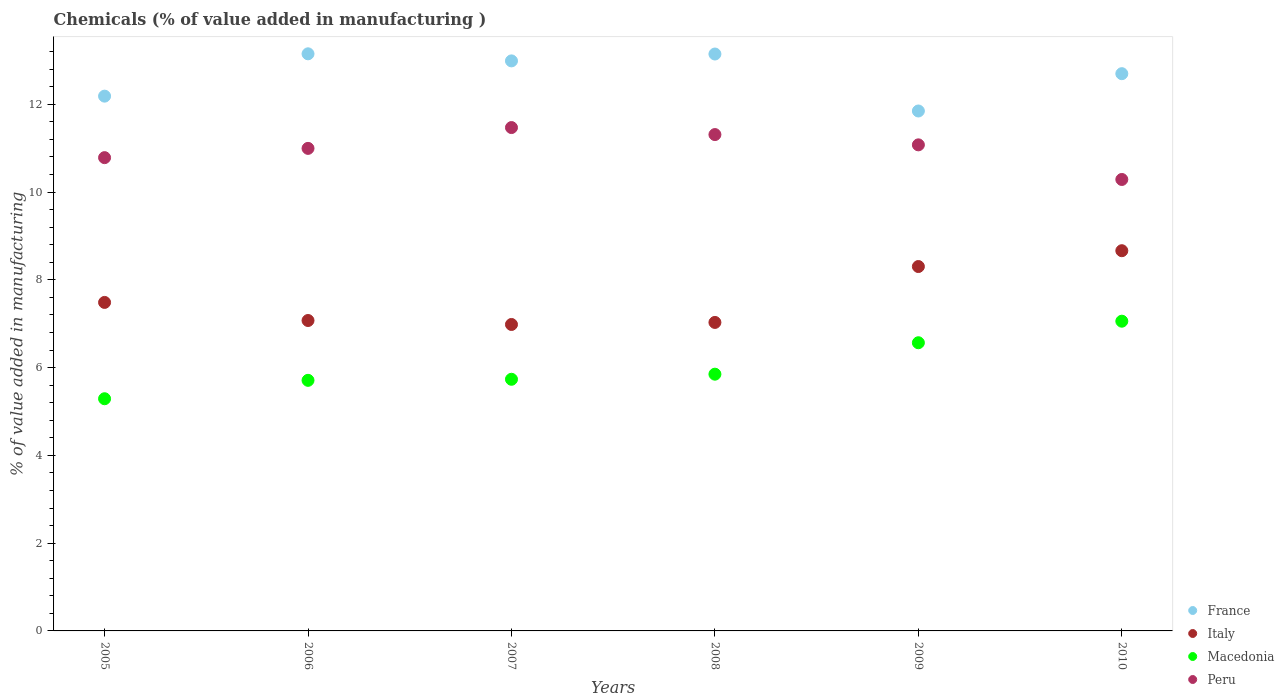What is the value added in manufacturing chemicals in Peru in 2010?
Offer a very short reply. 10.29. Across all years, what is the maximum value added in manufacturing chemicals in France?
Your response must be concise. 13.15. Across all years, what is the minimum value added in manufacturing chemicals in Peru?
Give a very brief answer. 10.29. In which year was the value added in manufacturing chemicals in France minimum?
Provide a succinct answer. 2009. What is the total value added in manufacturing chemicals in Macedonia in the graph?
Your response must be concise. 36.21. What is the difference between the value added in manufacturing chemicals in Italy in 2006 and that in 2008?
Provide a succinct answer. 0.04. What is the difference between the value added in manufacturing chemicals in Peru in 2006 and the value added in manufacturing chemicals in Macedonia in 2009?
Keep it short and to the point. 4.43. What is the average value added in manufacturing chemicals in Italy per year?
Your response must be concise. 7.59. In the year 2008, what is the difference between the value added in manufacturing chemicals in Peru and value added in manufacturing chemicals in France?
Your answer should be compact. -1.84. What is the ratio of the value added in manufacturing chemicals in Peru in 2005 to that in 2007?
Ensure brevity in your answer.  0.94. Is the value added in manufacturing chemicals in Peru in 2006 less than that in 2007?
Your answer should be very brief. Yes. Is the difference between the value added in manufacturing chemicals in Peru in 2009 and 2010 greater than the difference between the value added in manufacturing chemicals in France in 2009 and 2010?
Give a very brief answer. Yes. What is the difference between the highest and the second highest value added in manufacturing chemicals in France?
Your response must be concise. 0. What is the difference between the highest and the lowest value added in manufacturing chemicals in Peru?
Your response must be concise. 1.18. Does the value added in manufacturing chemicals in Peru monotonically increase over the years?
Offer a terse response. No. How many dotlines are there?
Keep it short and to the point. 4. How many years are there in the graph?
Provide a short and direct response. 6. Are the values on the major ticks of Y-axis written in scientific E-notation?
Your answer should be compact. No. How many legend labels are there?
Offer a terse response. 4. How are the legend labels stacked?
Your answer should be very brief. Vertical. What is the title of the graph?
Your response must be concise. Chemicals (% of value added in manufacturing ). Does "Greenland" appear as one of the legend labels in the graph?
Your answer should be compact. No. What is the label or title of the Y-axis?
Provide a short and direct response. % of value added in manufacturing. What is the % of value added in manufacturing of France in 2005?
Your response must be concise. 12.19. What is the % of value added in manufacturing in Italy in 2005?
Keep it short and to the point. 7.49. What is the % of value added in manufacturing in Macedonia in 2005?
Your answer should be very brief. 5.29. What is the % of value added in manufacturing of Peru in 2005?
Offer a terse response. 10.78. What is the % of value added in manufacturing of France in 2006?
Give a very brief answer. 13.15. What is the % of value added in manufacturing in Italy in 2006?
Your response must be concise. 7.07. What is the % of value added in manufacturing in Macedonia in 2006?
Provide a succinct answer. 5.71. What is the % of value added in manufacturing in Peru in 2006?
Offer a terse response. 11. What is the % of value added in manufacturing of France in 2007?
Your answer should be compact. 12.99. What is the % of value added in manufacturing in Italy in 2007?
Offer a very short reply. 6.98. What is the % of value added in manufacturing of Macedonia in 2007?
Offer a very short reply. 5.73. What is the % of value added in manufacturing in Peru in 2007?
Your response must be concise. 11.47. What is the % of value added in manufacturing in France in 2008?
Your answer should be compact. 13.15. What is the % of value added in manufacturing of Italy in 2008?
Keep it short and to the point. 7.03. What is the % of value added in manufacturing of Macedonia in 2008?
Your answer should be very brief. 5.85. What is the % of value added in manufacturing in Peru in 2008?
Your answer should be compact. 11.31. What is the % of value added in manufacturing in France in 2009?
Make the answer very short. 11.85. What is the % of value added in manufacturing of Italy in 2009?
Your response must be concise. 8.3. What is the % of value added in manufacturing of Macedonia in 2009?
Ensure brevity in your answer.  6.57. What is the % of value added in manufacturing of Peru in 2009?
Your answer should be compact. 11.08. What is the % of value added in manufacturing of France in 2010?
Provide a succinct answer. 12.7. What is the % of value added in manufacturing of Italy in 2010?
Offer a very short reply. 8.66. What is the % of value added in manufacturing in Macedonia in 2010?
Offer a terse response. 7.06. What is the % of value added in manufacturing in Peru in 2010?
Your answer should be very brief. 10.29. Across all years, what is the maximum % of value added in manufacturing in France?
Offer a very short reply. 13.15. Across all years, what is the maximum % of value added in manufacturing in Italy?
Offer a terse response. 8.66. Across all years, what is the maximum % of value added in manufacturing of Macedonia?
Ensure brevity in your answer.  7.06. Across all years, what is the maximum % of value added in manufacturing in Peru?
Ensure brevity in your answer.  11.47. Across all years, what is the minimum % of value added in manufacturing of France?
Your answer should be very brief. 11.85. Across all years, what is the minimum % of value added in manufacturing of Italy?
Provide a short and direct response. 6.98. Across all years, what is the minimum % of value added in manufacturing in Macedonia?
Make the answer very short. 5.29. Across all years, what is the minimum % of value added in manufacturing in Peru?
Keep it short and to the point. 10.29. What is the total % of value added in manufacturing in France in the graph?
Your response must be concise. 76.02. What is the total % of value added in manufacturing in Italy in the graph?
Your response must be concise. 45.54. What is the total % of value added in manufacturing of Macedonia in the graph?
Provide a short and direct response. 36.21. What is the total % of value added in manufacturing of Peru in the graph?
Ensure brevity in your answer.  65.92. What is the difference between the % of value added in manufacturing in France in 2005 and that in 2006?
Ensure brevity in your answer.  -0.96. What is the difference between the % of value added in manufacturing in Italy in 2005 and that in 2006?
Your response must be concise. 0.41. What is the difference between the % of value added in manufacturing in Macedonia in 2005 and that in 2006?
Your answer should be very brief. -0.42. What is the difference between the % of value added in manufacturing in Peru in 2005 and that in 2006?
Ensure brevity in your answer.  -0.21. What is the difference between the % of value added in manufacturing of France in 2005 and that in 2007?
Offer a terse response. -0.8. What is the difference between the % of value added in manufacturing in Italy in 2005 and that in 2007?
Make the answer very short. 0.5. What is the difference between the % of value added in manufacturing of Macedonia in 2005 and that in 2007?
Your response must be concise. -0.44. What is the difference between the % of value added in manufacturing of Peru in 2005 and that in 2007?
Provide a short and direct response. -0.69. What is the difference between the % of value added in manufacturing in France in 2005 and that in 2008?
Your answer should be compact. -0.96. What is the difference between the % of value added in manufacturing in Italy in 2005 and that in 2008?
Offer a very short reply. 0.46. What is the difference between the % of value added in manufacturing in Macedonia in 2005 and that in 2008?
Keep it short and to the point. -0.56. What is the difference between the % of value added in manufacturing in Peru in 2005 and that in 2008?
Offer a terse response. -0.53. What is the difference between the % of value added in manufacturing in France in 2005 and that in 2009?
Your answer should be compact. 0.34. What is the difference between the % of value added in manufacturing in Italy in 2005 and that in 2009?
Offer a terse response. -0.82. What is the difference between the % of value added in manufacturing in Macedonia in 2005 and that in 2009?
Offer a very short reply. -1.28. What is the difference between the % of value added in manufacturing of Peru in 2005 and that in 2009?
Ensure brevity in your answer.  -0.29. What is the difference between the % of value added in manufacturing in France in 2005 and that in 2010?
Your response must be concise. -0.51. What is the difference between the % of value added in manufacturing of Italy in 2005 and that in 2010?
Give a very brief answer. -1.18. What is the difference between the % of value added in manufacturing of Macedonia in 2005 and that in 2010?
Provide a short and direct response. -1.77. What is the difference between the % of value added in manufacturing in Peru in 2005 and that in 2010?
Provide a short and direct response. 0.5. What is the difference between the % of value added in manufacturing in France in 2006 and that in 2007?
Provide a succinct answer. 0.16. What is the difference between the % of value added in manufacturing in Italy in 2006 and that in 2007?
Provide a short and direct response. 0.09. What is the difference between the % of value added in manufacturing in Macedonia in 2006 and that in 2007?
Provide a short and direct response. -0.02. What is the difference between the % of value added in manufacturing of Peru in 2006 and that in 2007?
Provide a succinct answer. -0.47. What is the difference between the % of value added in manufacturing of France in 2006 and that in 2008?
Provide a short and direct response. 0. What is the difference between the % of value added in manufacturing of Italy in 2006 and that in 2008?
Your answer should be compact. 0.04. What is the difference between the % of value added in manufacturing of Macedonia in 2006 and that in 2008?
Ensure brevity in your answer.  -0.14. What is the difference between the % of value added in manufacturing of Peru in 2006 and that in 2008?
Give a very brief answer. -0.31. What is the difference between the % of value added in manufacturing in France in 2006 and that in 2009?
Provide a succinct answer. 1.3. What is the difference between the % of value added in manufacturing in Italy in 2006 and that in 2009?
Offer a terse response. -1.23. What is the difference between the % of value added in manufacturing in Macedonia in 2006 and that in 2009?
Your response must be concise. -0.86. What is the difference between the % of value added in manufacturing of Peru in 2006 and that in 2009?
Make the answer very short. -0.08. What is the difference between the % of value added in manufacturing in France in 2006 and that in 2010?
Ensure brevity in your answer.  0.45. What is the difference between the % of value added in manufacturing of Italy in 2006 and that in 2010?
Ensure brevity in your answer.  -1.59. What is the difference between the % of value added in manufacturing of Macedonia in 2006 and that in 2010?
Ensure brevity in your answer.  -1.35. What is the difference between the % of value added in manufacturing in Peru in 2006 and that in 2010?
Ensure brevity in your answer.  0.71. What is the difference between the % of value added in manufacturing of France in 2007 and that in 2008?
Ensure brevity in your answer.  -0.16. What is the difference between the % of value added in manufacturing of Italy in 2007 and that in 2008?
Give a very brief answer. -0.05. What is the difference between the % of value added in manufacturing of Macedonia in 2007 and that in 2008?
Make the answer very short. -0.12. What is the difference between the % of value added in manufacturing of Peru in 2007 and that in 2008?
Offer a very short reply. 0.16. What is the difference between the % of value added in manufacturing in France in 2007 and that in 2009?
Make the answer very short. 1.14. What is the difference between the % of value added in manufacturing of Italy in 2007 and that in 2009?
Make the answer very short. -1.32. What is the difference between the % of value added in manufacturing in Macedonia in 2007 and that in 2009?
Ensure brevity in your answer.  -0.83. What is the difference between the % of value added in manufacturing in Peru in 2007 and that in 2009?
Provide a succinct answer. 0.39. What is the difference between the % of value added in manufacturing in France in 2007 and that in 2010?
Keep it short and to the point. 0.29. What is the difference between the % of value added in manufacturing in Italy in 2007 and that in 2010?
Your response must be concise. -1.68. What is the difference between the % of value added in manufacturing in Macedonia in 2007 and that in 2010?
Make the answer very short. -1.32. What is the difference between the % of value added in manufacturing of Peru in 2007 and that in 2010?
Your answer should be compact. 1.18. What is the difference between the % of value added in manufacturing in France in 2008 and that in 2009?
Provide a short and direct response. 1.3. What is the difference between the % of value added in manufacturing of Italy in 2008 and that in 2009?
Your answer should be compact. -1.27. What is the difference between the % of value added in manufacturing of Macedonia in 2008 and that in 2009?
Keep it short and to the point. -0.72. What is the difference between the % of value added in manufacturing of Peru in 2008 and that in 2009?
Offer a terse response. 0.23. What is the difference between the % of value added in manufacturing of France in 2008 and that in 2010?
Give a very brief answer. 0.45. What is the difference between the % of value added in manufacturing in Italy in 2008 and that in 2010?
Your response must be concise. -1.63. What is the difference between the % of value added in manufacturing of Macedonia in 2008 and that in 2010?
Give a very brief answer. -1.21. What is the difference between the % of value added in manufacturing in Peru in 2008 and that in 2010?
Provide a succinct answer. 1.02. What is the difference between the % of value added in manufacturing in France in 2009 and that in 2010?
Your response must be concise. -0.85. What is the difference between the % of value added in manufacturing of Italy in 2009 and that in 2010?
Provide a succinct answer. -0.36. What is the difference between the % of value added in manufacturing in Macedonia in 2009 and that in 2010?
Your answer should be compact. -0.49. What is the difference between the % of value added in manufacturing in Peru in 2009 and that in 2010?
Provide a short and direct response. 0.79. What is the difference between the % of value added in manufacturing of France in 2005 and the % of value added in manufacturing of Italy in 2006?
Keep it short and to the point. 5.11. What is the difference between the % of value added in manufacturing in France in 2005 and the % of value added in manufacturing in Macedonia in 2006?
Your answer should be very brief. 6.48. What is the difference between the % of value added in manufacturing in France in 2005 and the % of value added in manufacturing in Peru in 2006?
Offer a very short reply. 1.19. What is the difference between the % of value added in manufacturing in Italy in 2005 and the % of value added in manufacturing in Macedonia in 2006?
Your answer should be very brief. 1.78. What is the difference between the % of value added in manufacturing of Italy in 2005 and the % of value added in manufacturing of Peru in 2006?
Your answer should be compact. -3.51. What is the difference between the % of value added in manufacturing of Macedonia in 2005 and the % of value added in manufacturing of Peru in 2006?
Your answer should be compact. -5.71. What is the difference between the % of value added in manufacturing of France in 2005 and the % of value added in manufacturing of Italy in 2007?
Offer a very short reply. 5.2. What is the difference between the % of value added in manufacturing in France in 2005 and the % of value added in manufacturing in Macedonia in 2007?
Ensure brevity in your answer.  6.45. What is the difference between the % of value added in manufacturing in France in 2005 and the % of value added in manufacturing in Peru in 2007?
Make the answer very short. 0.72. What is the difference between the % of value added in manufacturing of Italy in 2005 and the % of value added in manufacturing of Macedonia in 2007?
Your response must be concise. 1.75. What is the difference between the % of value added in manufacturing in Italy in 2005 and the % of value added in manufacturing in Peru in 2007?
Keep it short and to the point. -3.98. What is the difference between the % of value added in manufacturing of Macedonia in 2005 and the % of value added in manufacturing of Peru in 2007?
Ensure brevity in your answer.  -6.18. What is the difference between the % of value added in manufacturing in France in 2005 and the % of value added in manufacturing in Italy in 2008?
Provide a succinct answer. 5.16. What is the difference between the % of value added in manufacturing of France in 2005 and the % of value added in manufacturing of Macedonia in 2008?
Make the answer very short. 6.34. What is the difference between the % of value added in manufacturing in France in 2005 and the % of value added in manufacturing in Peru in 2008?
Offer a terse response. 0.88. What is the difference between the % of value added in manufacturing of Italy in 2005 and the % of value added in manufacturing of Macedonia in 2008?
Make the answer very short. 1.64. What is the difference between the % of value added in manufacturing of Italy in 2005 and the % of value added in manufacturing of Peru in 2008?
Make the answer very short. -3.82. What is the difference between the % of value added in manufacturing in Macedonia in 2005 and the % of value added in manufacturing in Peru in 2008?
Your answer should be very brief. -6.02. What is the difference between the % of value added in manufacturing in France in 2005 and the % of value added in manufacturing in Italy in 2009?
Make the answer very short. 3.88. What is the difference between the % of value added in manufacturing of France in 2005 and the % of value added in manufacturing of Macedonia in 2009?
Your answer should be compact. 5.62. What is the difference between the % of value added in manufacturing of France in 2005 and the % of value added in manufacturing of Peru in 2009?
Offer a terse response. 1.11. What is the difference between the % of value added in manufacturing of Italy in 2005 and the % of value added in manufacturing of Macedonia in 2009?
Offer a very short reply. 0.92. What is the difference between the % of value added in manufacturing in Italy in 2005 and the % of value added in manufacturing in Peru in 2009?
Your response must be concise. -3.59. What is the difference between the % of value added in manufacturing in Macedonia in 2005 and the % of value added in manufacturing in Peru in 2009?
Offer a very short reply. -5.79. What is the difference between the % of value added in manufacturing of France in 2005 and the % of value added in manufacturing of Italy in 2010?
Ensure brevity in your answer.  3.52. What is the difference between the % of value added in manufacturing of France in 2005 and the % of value added in manufacturing of Macedonia in 2010?
Make the answer very short. 5.13. What is the difference between the % of value added in manufacturing of France in 2005 and the % of value added in manufacturing of Peru in 2010?
Offer a terse response. 1.9. What is the difference between the % of value added in manufacturing in Italy in 2005 and the % of value added in manufacturing in Macedonia in 2010?
Provide a succinct answer. 0.43. What is the difference between the % of value added in manufacturing in Italy in 2005 and the % of value added in manufacturing in Peru in 2010?
Provide a short and direct response. -2.8. What is the difference between the % of value added in manufacturing of Macedonia in 2005 and the % of value added in manufacturing of Peru in 2010?
Your answer should be very brief. -5. What is the difference between the % of value added in manufacturing of France in 2006 and the % of value added in manufacturing of Italy in 2007?
Offer a very short reply. 6.17. What is the difference between the % of value added in manufacturing in France in 2006 and the % of value added in manufacturing in Macedonia in 2007?
Give a very brief answer. 7.42. What is the difference between the % of value added in manufacturing of France in 2006 and the % of value added in manufacturing of Peru in 2007?
Your answer should be compact. 1.68. What is the difference between the % of value added in manufacturing of Italy in 2006 and the % of value added in manufacturing of Macedonia in 2007?
Provide a short and direct response. 1.34. What is the difference between the % of value added in manufacturing of Italy in 2006 and the % of value added in manufacturing of Peru in 2007?
Your answer should be compact. -4.4. What is the difference between the % of value added in manufacturing of Macedonia in 2006 and the % of value added in manufacturing of Peru in 2007?
Offer a very short reply. -5.76. What is the difference between the % of value added in manufacturing in France in 2006 and the % of value added in manufacturing in Italy in 2008?
Ensure brevity in your answer.  6.12. What is the difference between the % of value added in manufacturing of France in 2006 and the % of value added in manufacturing of Macedonia in 2008?
Your answer should be compact. 7.3. What is the difference between the % of value added in manufacturing of France in 2006 and the % of value added in manufacturing of Peru in 2008?
Make the answer very short. 1.84. What is the difference between the % of value added in manufacturing in Italy in 2006 and the % of value added in manufacturing in Macedonia in 2008?
Make the answer very short. 1.22. What is the difference between the % of value added in manufacturing of Italy in 2006 and the % of value added in manufacturing of Peru in 2008?
Keep it short and to the point. -4.24. What is the difference between the % of value added in manufacturing of Macedonia in 2006 and the % of value added in manufacturing of Peru in 2008?
Offer a terse response. -5.6. What is the difference between the % of value added in manufacturing of France in 2006 and the % of value added in manufacturing of Italy in 2009?
Offer a very short reply. 4.85. What is the difference between the % of value added in manufacturing in France in 2006 and the % of value added in manufacturing in Macedonia in 2009?
Keep it short and to the point. 6.58. What is the difference between the % of value added in manufacturing in France in 2006 and the % of value added in manufacturing in Peru in 2009?
Offer a terse response. 2.07. What is the difference between the % of value added in manufacturing of Italy in 2006 and the % of value added in manufacturing of Macedonia in 2009?
Provide a short and direct response. 0.51. What is the difference between the % of value added in manufacturing of Italy in 2006 and the % of value added in manufacturing of Peru in 2009?
Provide a short and direct response. -4. What is the difference between the % of value added in manufacturing in Macedonia in 2006 and the % of value added in manufacturing in Peru in 2009?
Your answer should be very brief. -5.37. What is the difference between the % of value added in manufacturing in France in 2006 and the % of value added in manufacturing in Italy in 2010?
Offer a very short reply. 4.49. What is the difference between the % of value added in manufacturing in France in 2006 and the % of value added in manufacturing in Macedonia in 2010?
Provide a short and direct response. 6.09. What is the difference between the % of value added in manufacturing of France in 2006 and the % of value added in manufacturing of Peru in 2010?
Give a very brief answer. 2.86. What is the difference between the % of value added in manufacturing in Italy in 2006 and the % of value added in manufacturing in Macedonia in 2010?
Offer a terse response. 0.02. What is the difference between the % of value added in manufacturing of Italy in 2006 and the % of value added in manufacturing of Peru in 2010?
Give a very brief answer. -3.21. What is the difference between the % of value added in manufacturing in Macedonia in 2006 and the % of value added in manufacturing in Peru in 2010?
Your answer should be very brief. -4.58. What is the difference between the % of value added in manufacturing of France in 2007 and the % of value added in manufacturing of Italy in 2008?
Your response must be concise. 5.96. What is the difference between the % of value added in manufacturing in France in 2007 and the % of value added in manufacturing in Macedonia in 2008?
Offer a very short reply. 7.14. What is the difference between the % of value added in manufacturing of France in 2007 and the % of value added in manufacturing of Peru in 2008?
Ensure brevity in your answer.  1.68. What is the difference between the % of value added in manufacturing of Italy in 2007 and the % of value added in manufacturing of Macedonia in 2008?
Give a very brief answer. 1.13. What is the difference between the % of value added in manufacturing of Italy in 2007 and the % of value added in manufacturing of Peru in 2008?
Give a very brief answer. -4.33. What is the difference between the % of value added in manufacturing in Macedonia in 2007 and the % of value added in manufacturing in Peru in 2008?
Your response must be concise. -5.58. What is the difference between the % of value added in manufacturing of France in 2007 and the % of value added in manufacturing of Italy in 2009?
Make the answer very short. 4.69. What is the difference between the % of value added in manufacturing in France in 2007 and the % of value added in manufacturing in Macedonia in 2009?
Offer a very short reply. 6.42. What is the difference between the % of value added in manufacturing in France in 2007 and the % of value added in manufacturing in Peru in 2009?
Offer a terse response. 1.91. What is the difference between the % of value added in manufacturing in Italy in 2007 and the % of value added in manufacturing in Macedonia in 2009?
Provide a short and direct response. 0.42. What is the difference between the % of value added in manufacturing of Italy in 2007 and the % of value added in manufacturing of Peru in 2009?
Provide a succinct answer. -4.09. What is the difference between the % of value added in manufacturing of Macedonia in 2007 and the % of value added in manufacturing of Peru in 2009?
Provide a short and direct response. -5.34. What is the difference between the % of value added in manufacturing of France in 2007 and the % of value added in manufacturing of Italy in 2010?
Ensure brevity in your answer.  4.33. What is the difference between the % of value added in manufacturing in France in 2007 and the % of value added in manufacturing in Macedonia in 2010?
Give a very brief answer. 5.93. What is the difference between the % of value added in manufacturing in France in 2007 and the % of value added in manufacturing in Peru in 2010?
Your answer should be compact. 2.7. What is the difference between the % of value added in manufacturing in Italy in 2007 and the % of value added in manufacturing in Macedonia in 2010?
Ensure brevity in your answer.  -0.07. What is the difference between the % of value added in manufacturing in Italy in 2007 and the % of value added in manufacturing in Peru in 2010?
Offer a very short reply. -3.3. What is the difference between the % of value added in manufacturing of Macedonia in 2007 and the % of value added in manufacturing of Peru in 2010?
Your response must be concise. -4.55. What is the difference between the % of value added in manufacturing of France in 2008 and the % of value added in manufacturing of Italy in 2009?
Offer a terse response. 4.84. What is the difference between the % of value added in manufacturing of France in 2008 and the % of value added in manufacturing of Macedonia in 2009?
Ensure brevity in your answer.  6.58. What is the difference between the % of value added in manufacturing in France in 2008 and the % of value added in manufacturing in Peru in 2009?
Make the answer very short. 2.07. What is the difference between the % of value added in manufacturing of Italy in 2008 and the % of value added in manufacturing of Macedonia in 2009?
Ensure brevity in your answer.  0.46. What is the difference between the % of value added in manufacturing in Italy in 2008 and the % of value added in manufacturing in Peru in 2009?
Offer a very short reply. -4.05. What is the difference between the % of value added in manufacturing in Macedonia in 2008 and the % of value added in manufacturing in Peru in 2009?
Provide a succinct answer. -5.23. What is the difference between the % of value added in manufacturing of France in 2008 and the % of value added in manufacturing of Italy in 2010?
Ensure brevity in your answer.  4.48. What is the difference between the % of value added in manufacturing in France in 2008 and the % of value added in manufacturing in Macedonia in 2010?
Make the answer very short. 6.09. What is the difference between the % of value added in manufacturing in France in 2008 and the % of value added in manufacturing in Peru in 2010?
Provide a short and direct response. 2.86. What is the difference between the % of value added in manufacturing in Italy in 2008 and the % of value added in manufacturing in Macedonia in 2010?
Keep it short and to the point. -0.03. What is the difference between the % of value added in manufacturing of Italy in 2008 and the % of value added in manufacturing of Peru in 2010?
Make the answer very short. -3.26. What is the difference between the % of value added in manufacturing of Macedonia in 2008 and the % of value added in manufacturing of Peru in 2010?
Keep it short and to the point. -4.44. What is the difference between the % of value added in manufacturing in France in 2009 and the % of value added in manufacturing in Italy in 2010?
Offer a terse response. 3.18. What is the difference between the % of value added in manufacturing in France in 2009 and the % of value added in manufacturing in Macedonia in 2010?
Offer a terse response. 4.79. What is the difference between the % of value added in manufacturing in France in 2009 and the % of value added in manufacturing in Peru in 2010?
Your answer should be very brief. 1.56. What is the difference between the % of value added in manufacturing of Italy in 2009 and the % of value added in manufacturing of Macedonia in 2010?
Your answer should be very brief. 1.25. What is the difference between the % of value added in manufacturing of Italy in 2009 and the % of value added in manufacturing of Peru in 2010?
Offer a very short reply. -1.98. What is the difference between the % of value added in manufacturing in Macedonia in 2009 and the % of value added in manufacturing in Peru in 2010?
Offer a terse response. -3.72. What is the average % of value added in manufacturing in France per year?
Keep it short and to the point. 12.67. What is the average % of value added in manufacturing of Italy per year?
Offer a terse response. 7.59. What is the average % of value added in manufacturing of Macedonia per year?
Offer a very short reply. 6.04. What is the average % of value added in manufacturing of Peru per year?
Your response must be concise. 10.99. In the year 2005, what is the difference between the % of value added in manufacturing in France and % of value added in manufacturing in Italy?
Offer a terse response. 4.7. In the year 2005, what is the difference between the % of value added in manufacturing of France and % of value added in manufacturing of Macedonia?
Your answer should be compact. 6.9. In the year 2005, what is the difference between the % of value added in manufacturing of France and % of value added in manufacturing of Peru?
Offer a very short reply. 1.4. In the year 2005, what is the difference between the % of value added in manufacturing in Italy and % of value added in manufacturing in Macedonia?
Provide a short and direct response. 2.19. In the year 2005, what is the difference between the % of value added in manufacturing of Italy and % of value added in manufacturing of Peru?
Offer a very short reply. -3.3. In the year 2005, what is the difference between the % of value added in manufacturing of Macedonia and % of value added in manufacturing of Peru?
Provide a short and direct response. -5.49. In the year 2006, what is the difference between the % of value added in manufacturing in France and % of value added in manufacturing in Italy?
Offer a very short reply. 6.08. In the year 2006, what is the difference between the % of value added in manufacturing in France and % of value added in manufacturing in Macedonia?
Provide a succinct answer. 7.44. In the year 2006, what is the difference between the % of value added in manufacturing of France and % of value added in manufacturing of Peru?
Give a very brief answer. 2.15. In the year 2006, what is the difference between the % of value added in manufacturing in Italy and % of value added in manufacturing in Macedonia?
Your answer should be compact. 1.36. In the year 2006, what is the difference between the % of value added in manufacturing in Italy and % of value added in manufacturing in Peru?
Offer a terse response. -3.92. In the year 2006, what is the difference between the % of value added in manufacturing of Macedonia and % of value added in manufacturing of Peru?
Provide a short and direct response. -5.29. In the year 2007, what is the difference between the % of value added in manufacturing of France and % of value added in manufacturing of Italy?
Your answer should be compact. 6.01. In the year 2007, what is the difference between the % of value added in manufacturing in France and % of value added in manufacturing in Macedonia?
Ensure brevity in your answer.  7.25. In the year 2007, what is the difference between the % of value added in manufacturing of France and % of value added in manufacturing of Peru?
Provide a short and direct response. 1.52. In the year 2007, what is the difference between the % of value added in manufacturing in Italy and % of value added in manufacturing in Macedonia?
Offer a terse response. 1.25. In the year 2007, what is the difference between the % of value added in manufacturing in Italy and % of value added in manufacturing in Peru?
Provide a short and direct response. -4.49. In the year 2007, what is the difference between the % of value added in manufacturing in Macedonia and % of value added in manufacturing in Peru?
Your answer should be very brief. -5.74. In the year 2008, what is the difference between the % of value added in manufacturing of France and % of value added in manufacturing of Italy?
Your answer should be compact. 6.12. In the year 2008, what is the difference between the % of value added in manufacturing of France and % of value added in manufacturing of Macedonia?
Make the answer very short. 7.3. In the year 2008, what is the difference between the % of value added in manufacturing in France and % of value added in manufacturing in Peru?
Your answer should be very brief. 1.84. In the year 2008, what is the difference between the % of value added in manufacturing in Italy and % of value added in manufacturing in Macedonia?
Ensure brevity in your answer.  1.18. In the year 2008, what is the difference between the % of value added in manufacturing in Italy and % of value added in manufacturing in Peru?
Your response must be concise. -4.28. In the year 2008, what is the difference between the % of value added in manufacturing in Macedonia and % of value added in manufacturing in Peru?
Offer a terse response. -5.46. In the year 2009, what is the difference between the % of value added in manufacturing in France and % of value added in manufacturing in Italy?
Provide a succinct answer. 3.54. In the year 2009, what is the difference between the % of value added in manufacturing of France and % of value added in manufacturing of Macedonia?
Keep it short and to the point. 5.28. In the year 2009, what is the difference between the % of value added in manufacturing in France and % of value added in manufacturing in Peru?
Keep it short and to the point. 0.77. In the year 2009, what is the difference between the % of value added in manufacturing in Italy and % of value added in manufacturing in Macedonia?
Give a very brief answer. 1.74. In the year 2009, what is the difference between the % of value added in manufacturing in Italy and % of value added in manufacturing in Peru?
Your response must be concise. -2.77. In the year 2009, what is the difference between the % of value added in manufacturing in Macedonia and % of value added in manufacturing in Peru?
Provide a short and direct response. -4.51. In the year 2010, what is the difference between the % of value added in manufacturing in France and % of value added in manufacturing in Italy?
Make the answer very short. 4.03. In the year 2010, what is the difference between the % of value added in manufacturing of France and % of value added in manufacturing of Macedonia?
Offer a terse response. 5.64. In the year 2010, what is the difference between the % of value added in manufacturing of France and % of value added in manufacturing of Peru?
Ensure brevity in your answer.  2.41. In the year 2010, what is the difference between the % of value added in manufacturing of Italy and % of value added in manufacturing of Macedonia?
Your response must be concise. 1.61. In the year 2010, what is the difference between the % of value added in manufacturing of Italy and % of value added in manufacturing of Peru?
Give a very brief answer. -1.62. In the year 2010, what is the difference between the % of value added in manufacturing in Macedonia and % of value added in manufacturing in Peru?
Your response must be concise. -3.23. What is the ratio of the % of value added in manufacturing of France in 2005 to that in 2006?
Keep it short and to the point. 0.93. What is the ratio of the % of value added in manufacturing in Italy in 2005 to that in 2006?
Keep it short and to the point. 1.06. What is the ratio of the % of value added in manufacturing of Macedonia in 2005 to that in 2006?
Offer a terse response. 0.93. What is the ratio of the % of value added in manufacturing in Peru in 2005 to that in 2006?
Your answer should be compact. 0.98. What is the ratio of the % of value added in manufacturing in France in 2005 to that in 2007?
Offer a very short reply. 0.94. What is the ratio of the % of value added in manufacturing in Italy in 2005 to that in 2007?
Your response must be concise. 1.07. What is the ratio of the % of value added in manufacturing of Macedonia in 2005 to that in 2007?
Offer a terse response. 0.92. What is the ratio of the % of value added in manufacturing of Peru in 2005 to that in 2007?
Make the answer very short. 0.94. What is the ratio of the % of value added in manufacturing in France in 2005 to that in 2008?
Ensure brevity in your answer.  0.93. What is the ratio of the % of value added in manufacturing in Italy in 2005 to that in 2008?
Provide a succinct answer. 1.06. What is the ratio of the % of value added in manufacturing of Macedonia in 2005 to that in 2008?
Ensure brevity in your answer.  0.9. What is the ratio of the % of value added in manufacturing in Peru in 2005 to that in 2008?
Offer a very short reply. 0.95. What is the ratio of the % of value added in manufacturing in France in 2005 to that in 2009?
Provide a short and direct response. 1.03. What is the ratio of the % of value added in manufacturing in Italy in 2005 to that in 2009?
Ensure brevity in your answer.  0.9. What is the ratio of the % of value added in manufacturing of Macedonia in 2005 to that in 2009?
Your answer should be compact. 0.81. What is the ratio of the % of value added in manufacturing in Peru in 2005 to that in 2009?
Give a very brief answer. 0.97. What is the ratio of the % of value added in manufacturing of France in 2005 to that in 2010?
Ensure brevity in your answer.  0.96. What is the ratio of the % of value added in manufacturing of Italy in 2005 to that in 2010?
Ensure brevity in your answer.  0.86. What is the ratio of the % of value added in manufacturing in Macedonia in 2005 to that in 2010?
Provide a short and direct response. 0.75. What is the ratio of the % of value added in manufacturing in Peru in 2005 to that in 2010?
Give a very brief answer. 1.05. What is the ratio of the % of value added in manufacturing of France in 2006 to that in 2007?
Offer a very short reply. 1.01. What is the ratio of the % of value added in manufacturing in Macedonia in 2006 to that in 2007?
Your answer should be compact. 1. What is the ratio of the % of value added in manufacturing in Peru in 2006 to that in 2007?
Make the answer very short. 0.96. What is the ratio of the % of value added in manufacturing in Macedonia in 2006 to that in 2008?
Your response must be concise. 0.98. What is the ratio of the % of value added in manufacturing of Peru in 2006 to that in 2008?
Your answer should be very brief. 0.97. What is the ratio of the % of value added in manufacturing in France in 2006 to that in 2009?
Provide a succinct answer. 1.11. What is the ratio of the % of value added in manufacturing of Italy in 2006 to that in 2009?
Offer a very short reply. 0.85. What is the ratio of the % of value added in manufacturing of Macedonia in 2006 to that in 2009?
Keep it short and to the point. 0.87. What is the ratio of the % of value added in manufacturing in France in 2006 to that in 2010?
Your response must be concise. 1.04. What is the ratio of the % of value added in manufacturing in Italy in 2006 to that in 2010?
Offer a very short reply. 0.82. What is the ratio of the % of value added in manufacturing in Macedonia in 2006 to that in 2010?
Offer a terse response. 0.81. What is the ratio of the % of value added in manufacturing in Peru in 2006 to that in 2010?
Offer a very short reply. 1.07. What is the ratio of the % of value added in manufacturing of Macedonia in 2007 to that in 2008?
Keep it short and to the point. 0.98. What is the ratio of the % of value added in manufacturing in Peru in 2007 to that in 2008?
Provide a succinct answer. 1.01. What is the ratio of the % of value added in manufacturing of France in 2007 to that in 2009?
Make the answer very short. 1.1. What is the ratio of the % of value added in manufacturing in Italy in 2007 to that in 2009?
Your answer should be compact. 0.84. What is the ratio of the % of value added in manufacturing in Macedonia in 2007 to that in 2009?
Keep it short and to the point. 0.87. What is the ratio of the % of value added in manufacturing in Peru in 2007 to that in 2009?
Provide a succinct answer. 1.04. What is the ratio of the % of value added in manufacturing of France in 2007 to that in 2010?
Make the answer very short. 1.02. What is the ratio of the % of value added in manufacturing of Italy in 2007 to that in 2010?
Your answer should be compact. 0.81. What is the ratio of the % of value added in manufacturing in Macedonia in 2007 to that in 2010?
Your answer should be compact. 0.81. What is the ratio of the % of value added in manufacturing in Peru in 2007 to that in 2010?
Your answer should be compact. 1.11. What is the ratio of the % of value added in manufacturing in France in 2008 to that in 2009?
Ensure brevity in your answer.  1.11. What is the ratio of the % of value added in manufacturing in Italy in 2008 to that in 2009?
Offer a terse response. 0.85. What is the ratio of the % of value added in manufacturing of Macedonia in 2008 to that in 2009?
Your answer should be very brief. 0.89. What is the ratio of the % of value added in manufacturing of Peru in 2008 to that in 2009?
Your answer should be compact. 1.02. What is the ratio of the % of value added in manufacturing of France in 2008 to that in 2010?
Ensure brevity in your answer.  1.04. What is the ratio of the % of value added in manufacturing of Italy in 2008 to that in 2010?
Provide a succinct answer. 0.81. What is the ratio of the % of value added in manufacturing of Macedonia in 2008 to that in 2010?
Offer a very short reply. 0.83. What is the ratio of the % of value added in manufacturing in Peru in 2008 to that in 2010?
Make the answer very short. 1.1. What is the ratio of the % of value added in manufacturing in France in 2009 to that in 2010?
Make the answer very short. 0.93. What is the ratio of the % of value added in manufacturing in Italy in 2009 to that in 2010?
Make the answer very short. 0.96. What is the ratio of the % of value added in manufacturing of Macedonia in 2009 to that in 2010?
Ensure brevity in your answer.  0.93. What is the ratio of the % of value added in manufacturing of Peru in 2009 to that in 2010?
Offer a very short reply. 1.08. What is the difference between the highest and the second highest % of value added in manufacturing in France?
Provide a short and direct response. 0. What is the difference between the highest and the second highest % of value added in manufacturing of Italy?
Your answer should be very brief. 0.36. What is the difference between the highest and the second highest % of value added in manufacturing in Macedonia?
Provide a succinct answer. 0.49. What is the difference between the highest and the second highest % of value added in manufacturing of Peru?
Provide a succinct answer. 0.16. What is the difference between the highest and the lowest % of value added in manufacturing in France?
Make the answer very short. 1.3. What is the difference between the highest and the lowest % of value added in manufacturing in Italy?
Give a very brief answer. 1.68. What is the difference between the highest and the lowest % of value added in manufacturing in Macedonia?
Make the answer very short. 1.77. What is the difference between the highest and the lowest % of value added in manufacturing of Peru?
Provide a short and direct response. 1.18. 